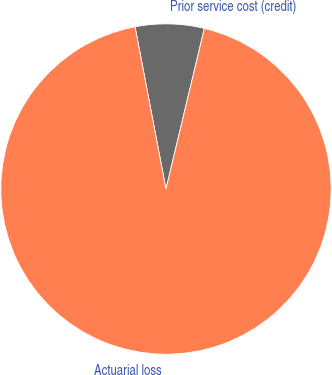Convert chart. <chart><loc_0><loc_0><loc_500><loc_500><pie_chart><fcel>Prior service cost (credit)<fcel>Actuarial loss<nl><fcel>6.73%<fcel>93.27%<nl></chart> 